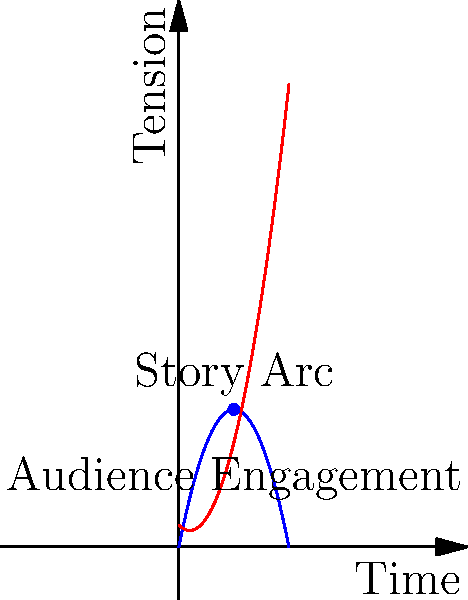In a screenwriter's story arc, the dramatic tension $T(t)$ is modeled by the function $T(t) = -0.5t^2 + 5t$, where $t$ represents time in hours. The audience engagement $E(t)$ is given by $E(t) = 0.5t^2 - t + 2$. At what time does the story reach its peak dramatic tension, and what is the difference between the tension and engagement at this point? To solve this problem, we'll follow these steps:

1) First, we need to find the time when the dramatic tension reaches its peak. This occurs when the derivative of $T(t)$ equals zero.

   $T(t) = -0.5t^2 + 5t$
   $T'(t) = -t + 5$

   Set $T'(t) = 0$:
   $-t + 5 = 0$
   $t = 5$

2) Now we know the peak tension occurs at $t = 5$ hours.

3) Let's calculate the tension at this point:
   $T(5) = -0.5(5)^2 + 5(5) = -12.5 + 25 = 12.5$

4) Next, we'll calculate the audience engagement at this point:
   $E(5) = 0.5(5)^2 - 5 + 2 = 12.5 - 5 + 2 = 9.5$

5) The difference between tension and engagement at $t = 5$ is:
   $12.5 - 9.5 = 3$

Therefore, the story reaches its peak dramatic tension at 5 hours, and at this point, the tension exceeds the engagement by 3 units.
Answer: 5 hours; 3 units 